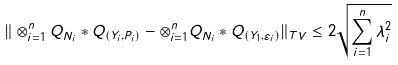<formula> <loc_0><loc_0><loc_500><loc_500>\| \otimes _ { i = 1 } ^ { n } Q _ { N _ { i } } * Q _ { ( Y _ { i } , P _ { i } ) } - \otimes _ { i = 1 } ^ { n } Q _ { N _ { i } } * Q _ { ( Y _ { 1 } , \varepsilon _ { i } ) } \| _ { T V } \leq 2 \sqrt { \sum _ { i = 1 } ^ { n } \lambda _ { i } ^ { 2 } }</formula> 